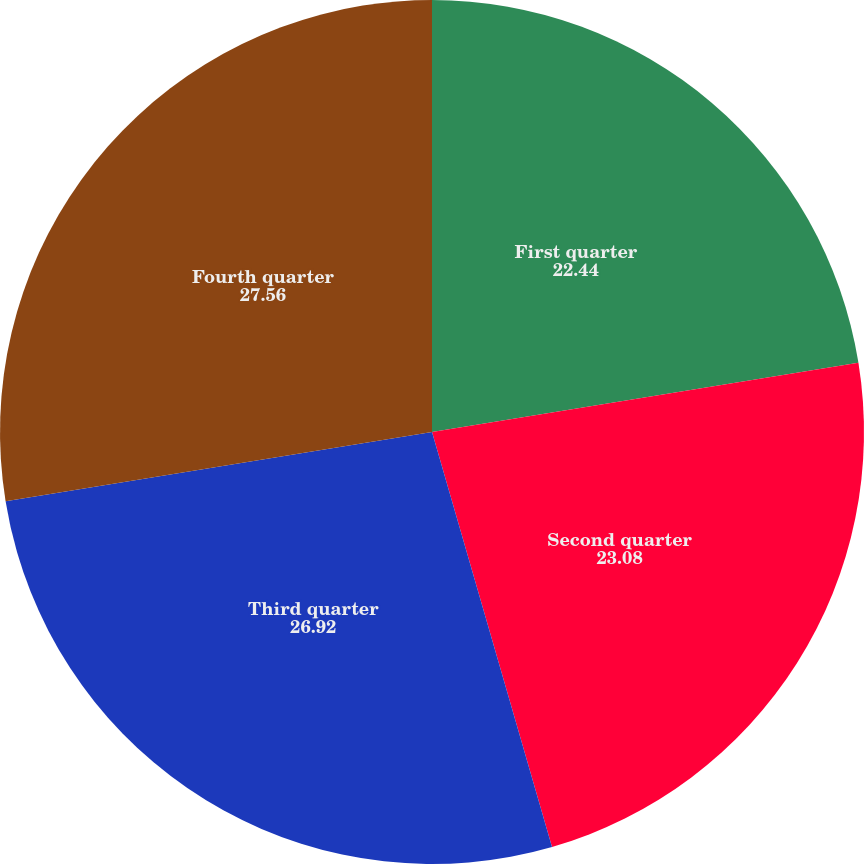Convert chart. <chart><loc_0><loc_0><loc_500><loc_500><pie_chart><fcel>First quarter<fcel>Second quarter<fcel>Third quarter<fcel>Fourth quarter<nl><fcel>22.44%<fcel>23.08%<fcel>26.92%<fcel>27.56%<nl></chart> 